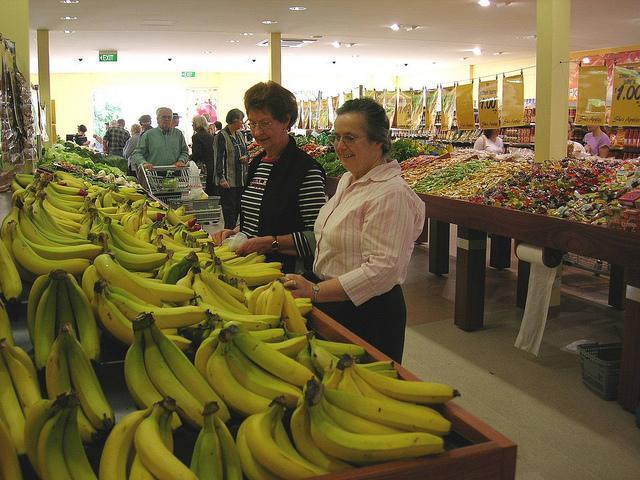How many people are in the photo?
Give a very brief answer. 4. How many bananas are in the photo?
Give a very brief answer. 9. How many bird are visible?
Give a very brief answer. 0. 